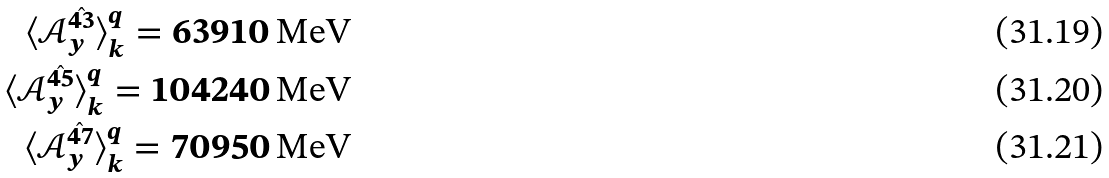<formula> <loc_0><loc_0><loc_500><loc_500>\langle \mathcal { A } _ { y } ^ { \hat { 4 3 } } \rangle ^ { q } _ { k } = 6 3 9 1 0 \, \text {MeV} \\ \langle \mathcal { A } _ { y } ^ { \hat { 4 5 } } \rangle ^ { q } _ { k } = 1 0 4 2 4 0 \, \text {MeV} \\ \langle \mathcal { A } _ { y } ^ { \hat { 4 7 } } \rangle ^ { q } _ { k } = 7 0 9 5 0 \, \text {MeV}</formula> 